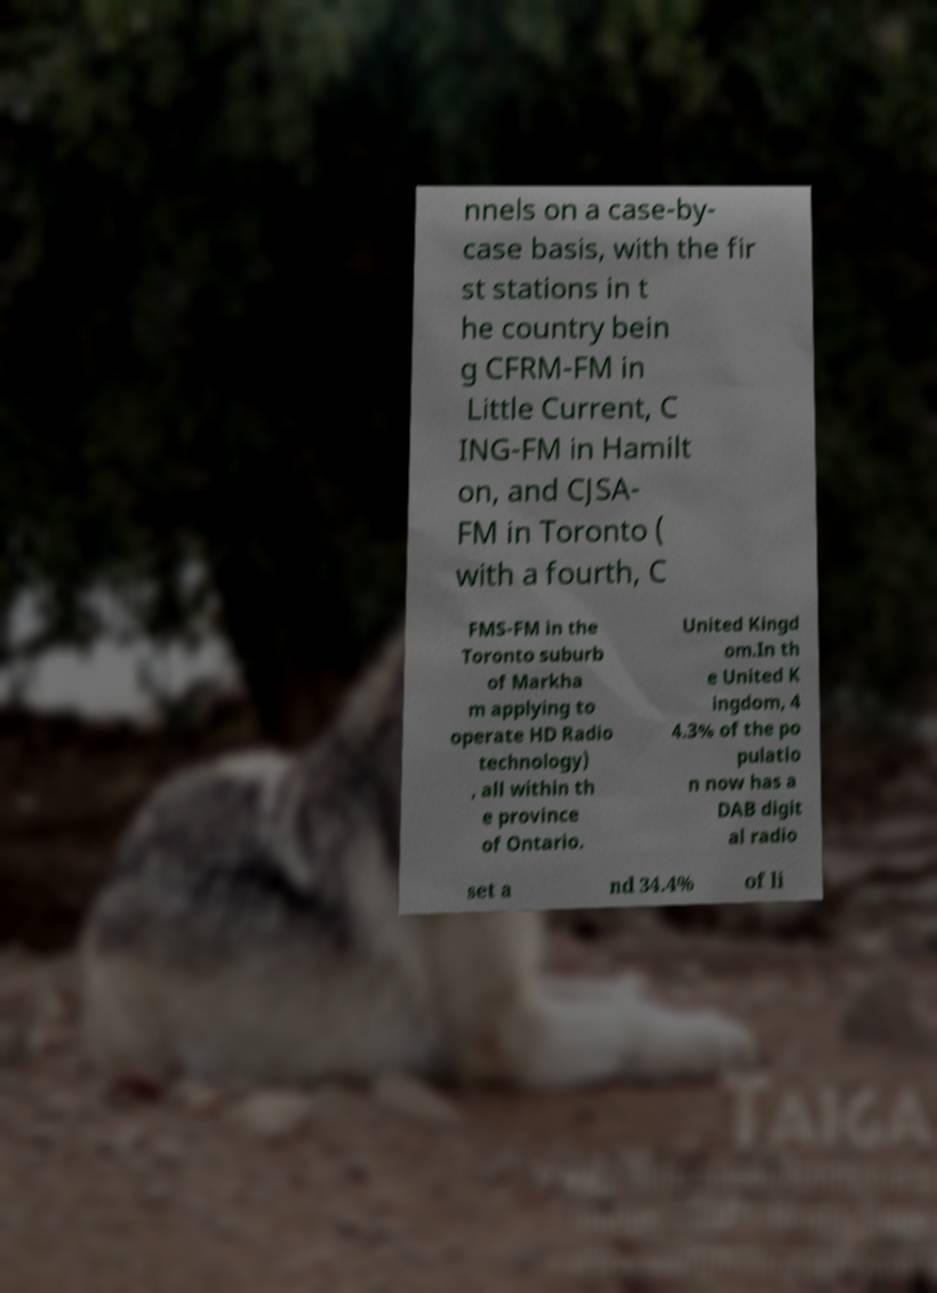For documentation purposes, I need the text within this image transcribed. Could you provide that? nnels on a case-by- case basis, with the fir st stations in t he country bein g CFRM-FM in Little Current, C ING-FM in Hamilt on, and CJSA- FM in Toronto ( with a fourth, C FMS-FM in the Toronto suburb of Markha m applying to operate HD Radio technology) , all within th e province of Ontario. United Kingd om.In th e United K ingdom, 4 4.3% of the po pulatio n now has a DAB digit al radio set a nd 34.4% of li 